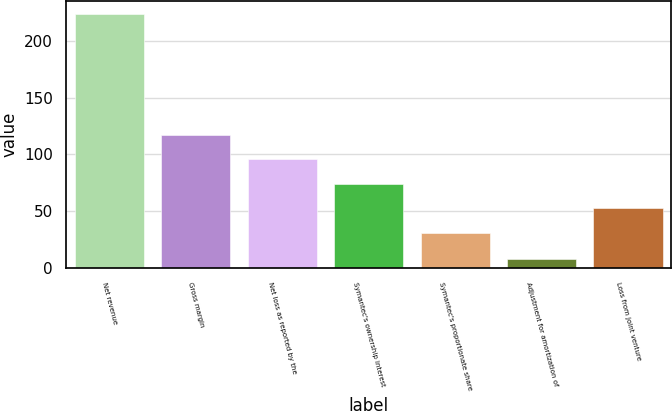<chart> <loc_0><loc_0><loc_500><loc_500><bar_chart><fcel>Net revenue<fcel>Gross margin<fcel>Net loss as reported by the<fcel>Symantec's ownership interest<fcel>Symantec's proportionate share<fcel>Adjustment for amortization of<fcel>Loss from joint venture<nl><fcel>224<fcel>117.4<fcel>95.8<fcel>74.2<fcel>31<fcel>8<fcel>52.6<nl></chart> 